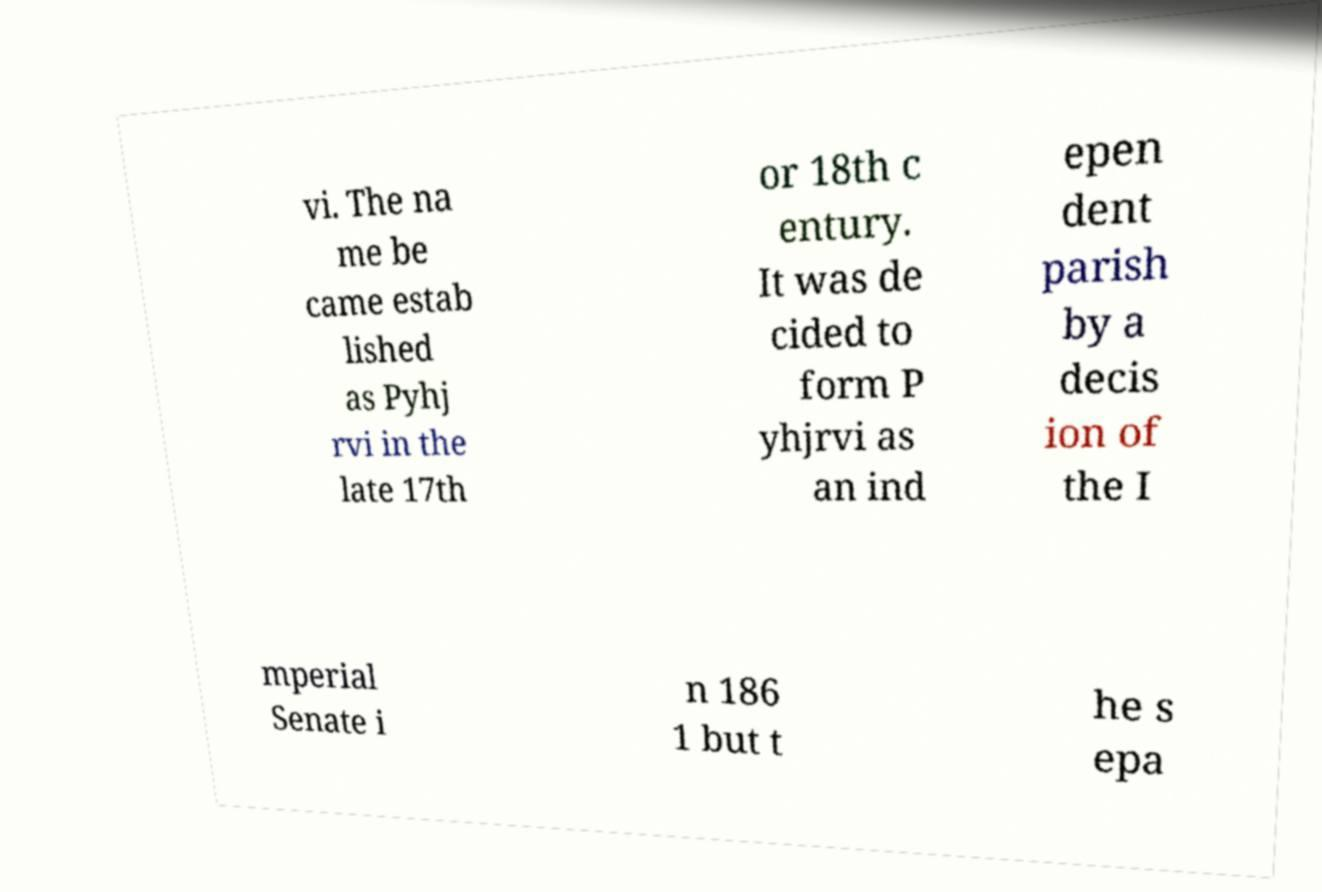Can you accurately transcribe the text from the provided image for me? vi. The na me be came estab lished as Pyhj rvi in the late 17th or 18th c entury. It was de cided to form P yhjrvi as an ind epen dent parish by a decis ion of the I mperial Senate i n 186 1 but t he s epa 